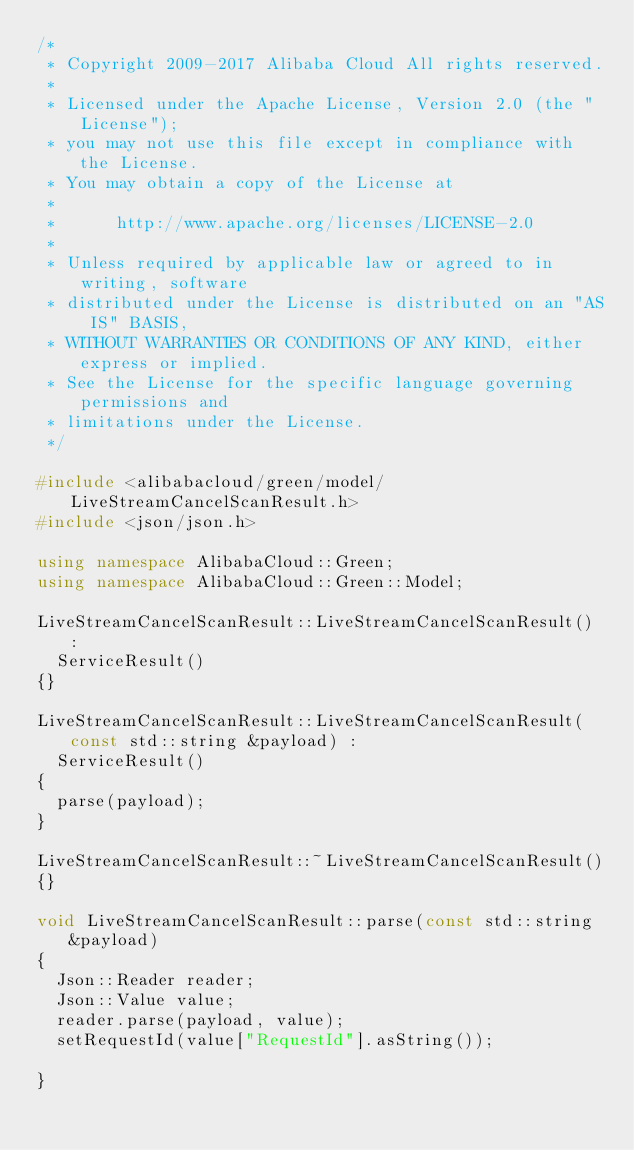<code> <loc_0><loc_0><loc_500><loc_500><_C++_>/*
 * Copyright 2009-2017 Alibaba Cloud All rights reserved.
 * 
 * Licensed under the Apache License, Version 2.0 (the "License");
 * you may not use this file except in compliance with the License.
 * You may obtain a copy of the License at
 * 
 *      http://www.apache.org/licenses/LICENSE-2.0
 * 
 * Unless required by applicable law or agreed to in writing, software
 * distributed under the License is distributed on an "AS IS" BASIS,
 * WITHOUT WARRANTIES OR CONDITIONS OF ANY KIND, either express or implied.
 * See the License for the specific language governing permissions and
 * limitations under the License.
 */

#include <alibabacloud/green/model/LiveStreamCancelScanResult.h>
#include <json/json.h>

using namespace AlibabaCloud::Green;
using namespace AlibabaCloud::Green::Model;

LiveStreamCancelScanResult::LiveStreamCancelScanResult() :
	ServiceResult()
{}

LiveStreamCancelScanResult::LiveStreamCancelScanResult(const std::string &payload) :
	ServiceResult()
{
	parse(payload);
}

LiveStreamCancelScanResult::~LiveStreamCancelScanResult()
{}

void LiveStreamCancelScanResult::parse(const std::string &payload)
{
	Json::Reader reader;
	Json::Value value;
	reader.parse(payload, value);
	setRequestId(value["RequestId"].asString());

}

</code> 